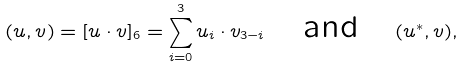Convert formula to latex. <formula><loc_0><loc_0><loc_500><loc_500>( u , v ) = [ u \cdot v ] _ { 6 } = \sum _ { i = 0 } ^ { 3 } u _ { i } \cdot v _ { 3 - i } \quad \text {and} \quad ( u ^ { * } , v ) ,</formula> 